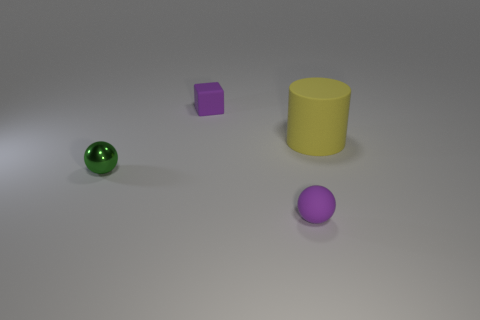Add 1 tiny green metal cubes. How many objects exist? 5 Subtract all cubes. How many objects are left? 3 Subtract all small cyan metallic cylinders. Subtract all shiny objects. How many objects are left? 3 Add 3 small things. How many small things are left? 6 Add 2 cyan shiny cubes. How many cyan shiny cubes exist? 2 Subtract 0 blue cylinders. How many objects are left? 4 